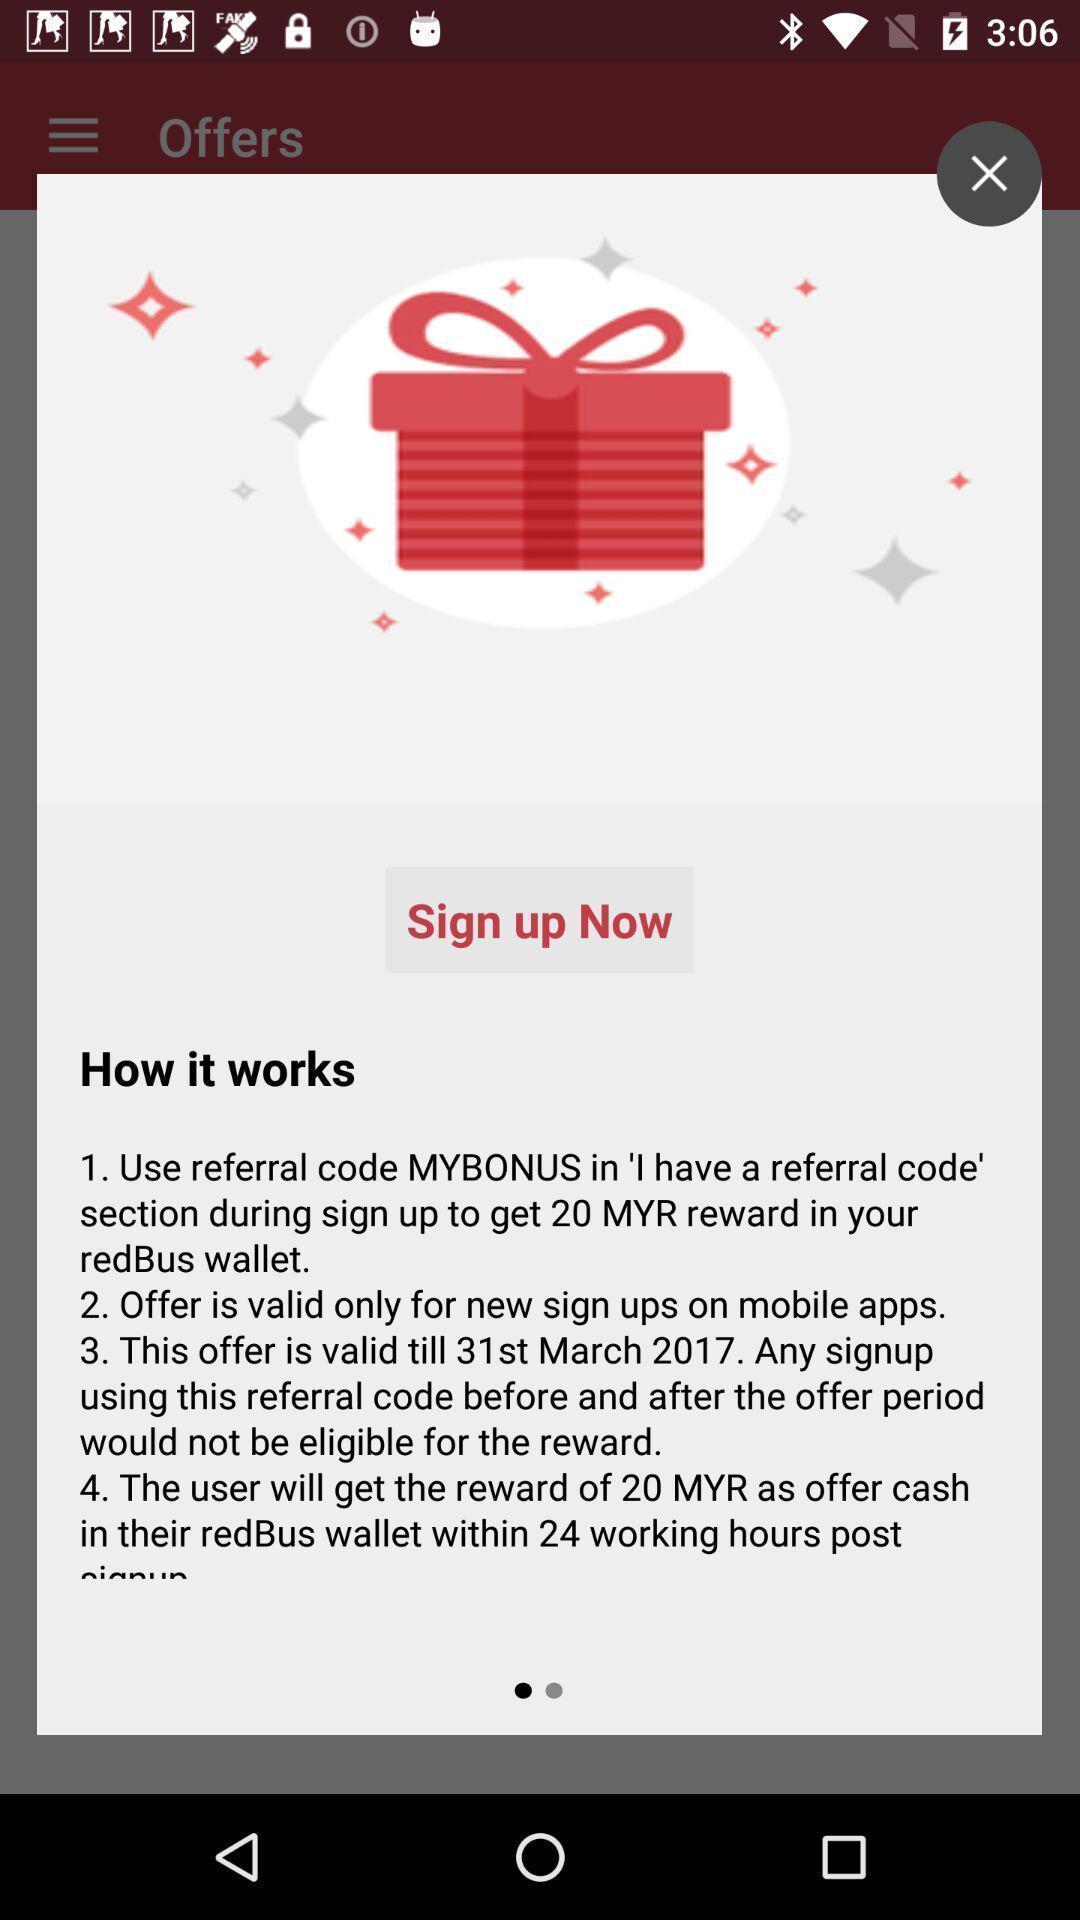Describe the key features of this screenshot. Popup page with instruction for sign up. 